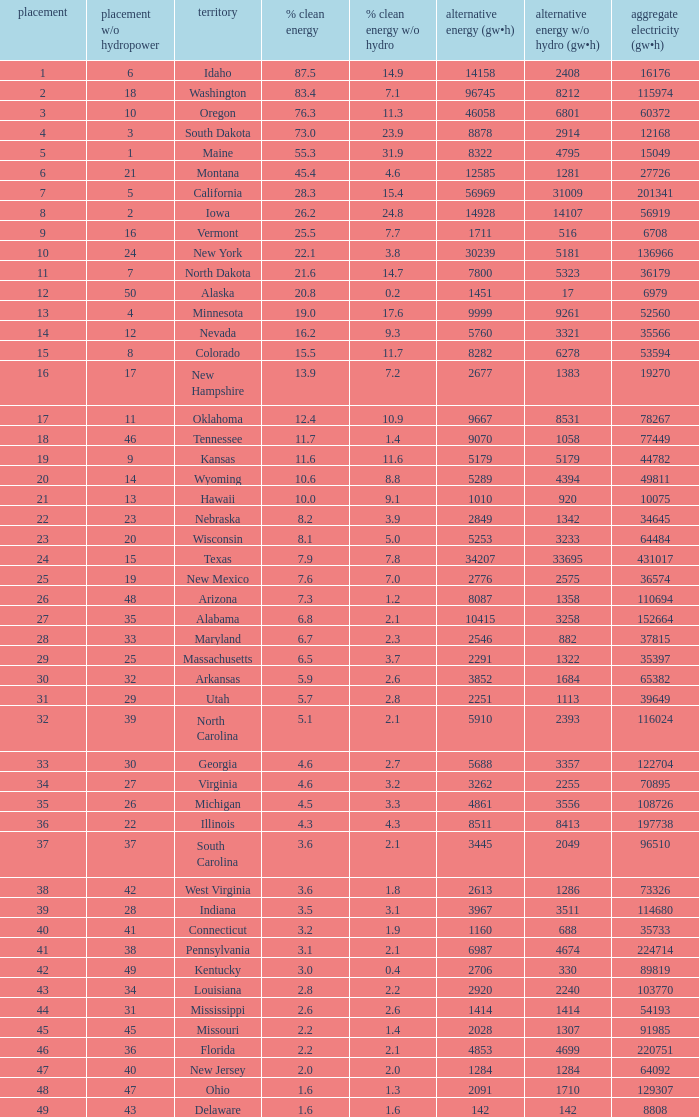What is the maximum renewable energy (gw×h) for the state of Delaware? 142.0. 